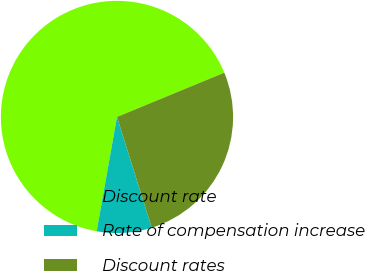Convert chart to OTSL. <chart><loc_0><loc_0><loc_500><loc_500><pie_chart><fcel>Discount rate<fcel>Rate of compensation increase<fcel>Discount rates<nl><fcel>65.97%<fcel>7.64%<fcel>26.39%<nl></chart> 